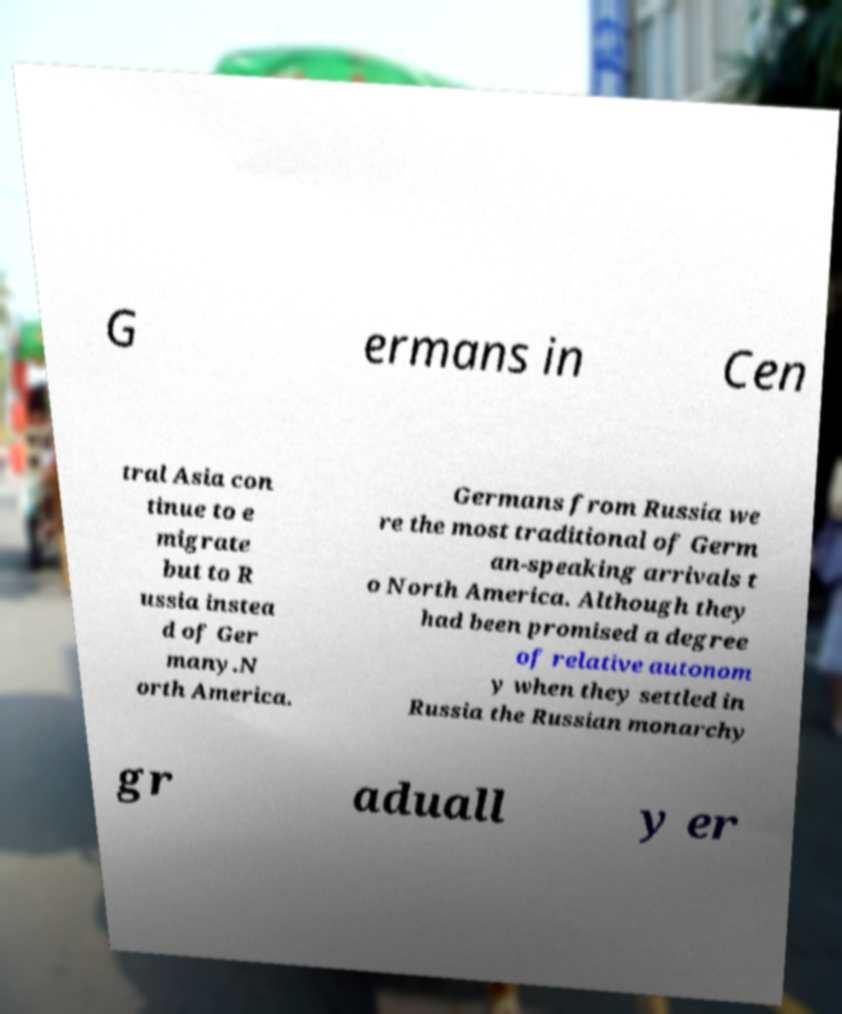Could you extract and type out the text from this image? G ermans in Cen tral Asia con tinue to e migrate but to R ussia instea d of Ger many.N orth America. Germans from Russia we re the most traditional of Germ an-speaking arrivals t o North America. Although they had been promised a degree of relative autonom y when they settled in Russia the Russian monarchy gr aduall y er 